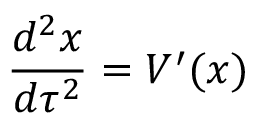Convert formula to latex. <formula><loc_0><loc_0><loc_500><loc_500>{ \frac { d ^ { 2 } x } { d \tau ^ { 2 } } } = V ^ { \prime } ( x )</formula> 